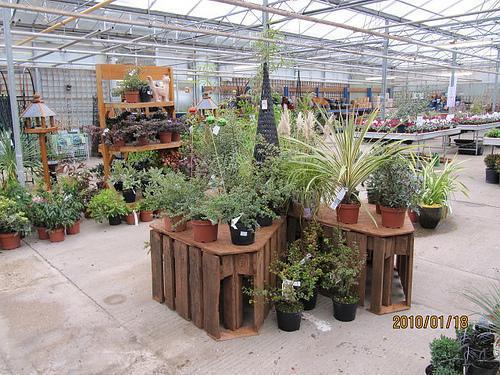How many potted plants are there?
Give a very brief answer. 8. 